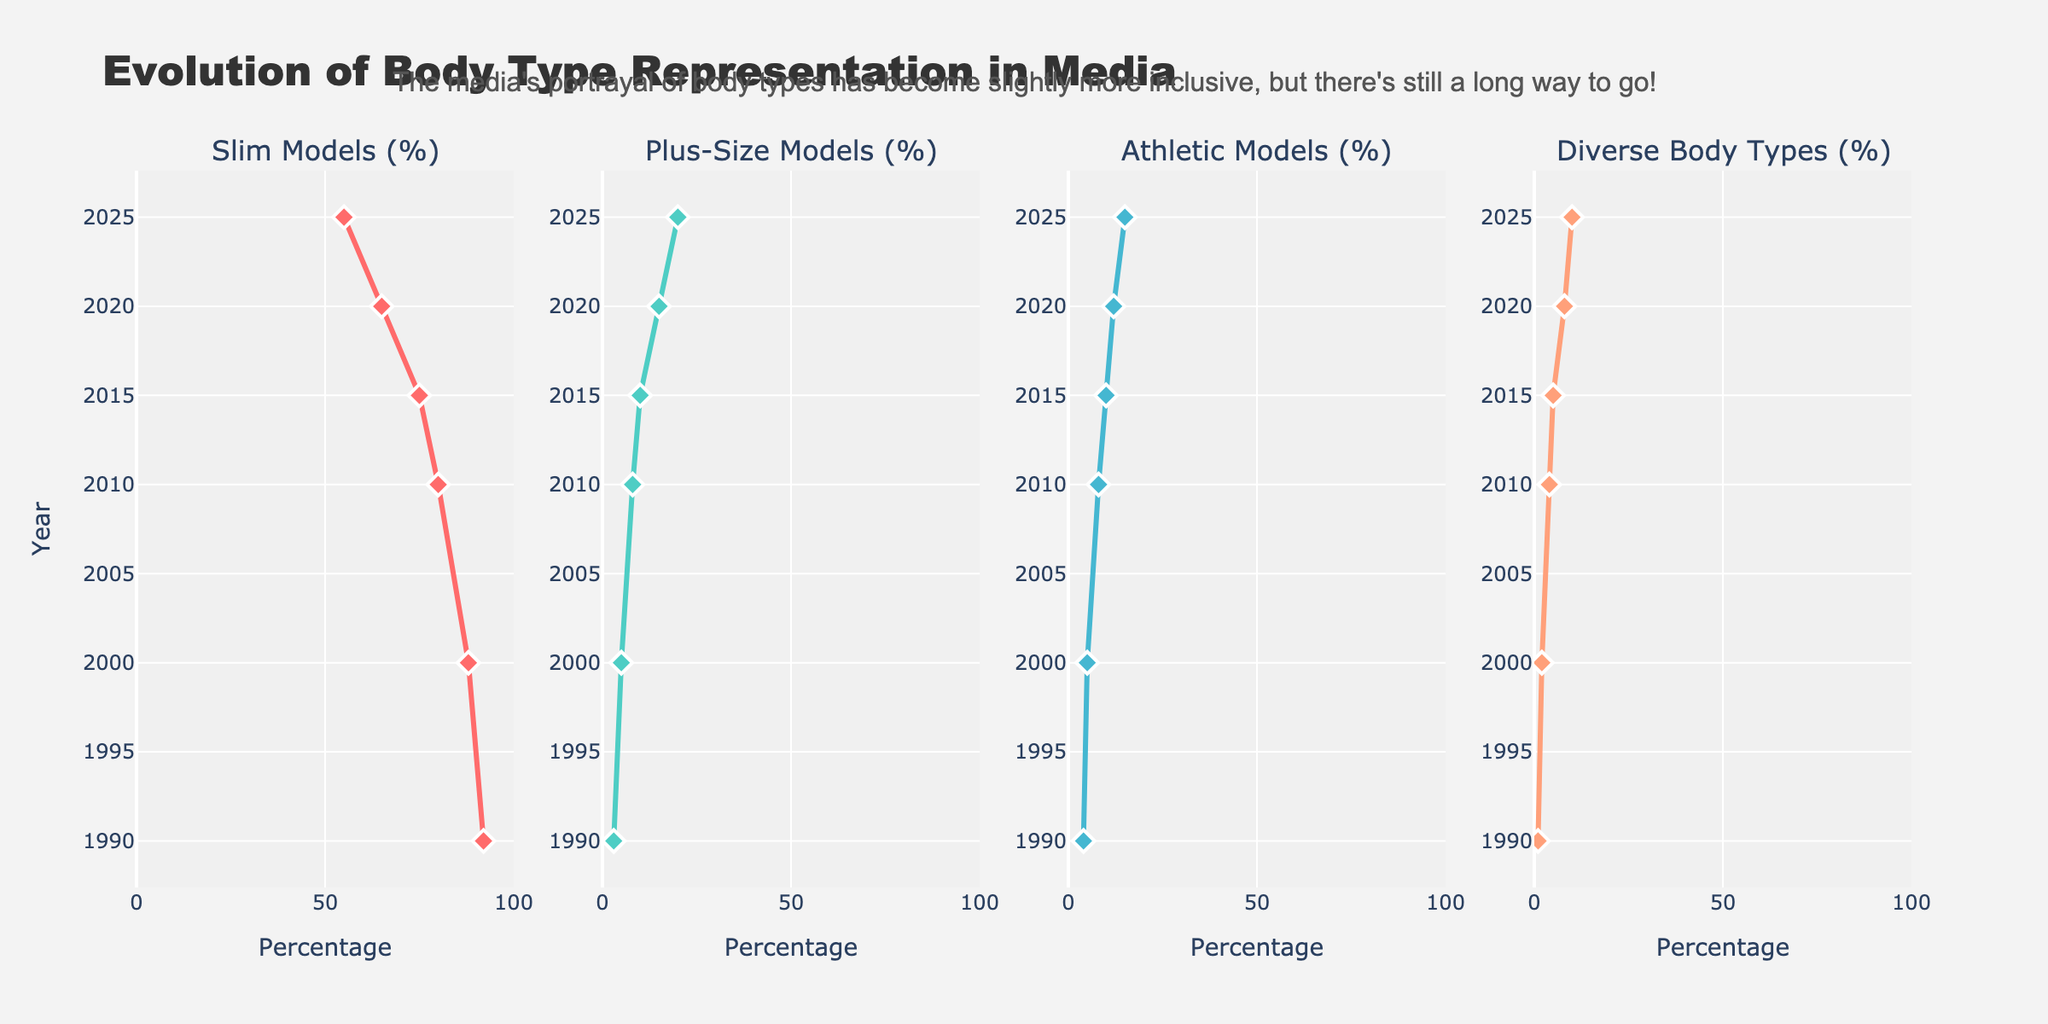What is the title of the figure? The title is located at the top of the figure and is intended to describe the main subject of the visualization.
Answer: Evolution of Body Type Representation in Media How has the percentage of slim models changed from 1990 to 2025? Look at the first subplot and compare the percentages shown for the years 1990 and 2025. In 1990, the percentage is 92%, and in 2025, it is 55%.
Answer: It has decreased from 92% to 55% Which year shows an equal percentage for both plus-size and athletic models? Check both the plus-size models (% in the second subplot) and athletic models (% in the third subplot) to find the year when both percentages match. The desired year should have equal percentages in both columns.
Answer: 2000 By what factor has the representation of diverse body types increased from 1990 to 2025? Calculate the ratio of the percentage of diverse body types in 2025 to that in 1990. The values are 10% for 2025 and 1% for 1990. Thus, Divide 10 by 1 to get the factor.
Answer: 10 In which year did the representation of athletic models first reach double digits? Examine the third subplot and identify the first year when the percentage is 10% or greater. This is in the year wise order of the data points.
Answer: 2015 Which body type has shown the greatest increase in representation between 1990 and 2025? Calculate the percentage increase for each body type: subtract the 1990 percentage from the 2025 percentage and find the type with the highest change.
Answer: Plus-Size Models How does the change in representation of plus-size models between 1990 and 2025 compare to the change in representation of diverse body types over the same period? Calculate the percentage increase for both plus-size models and diverse body types from 1990 to 2025. Plus-size models increased from 3% to 20% and diverse body types from 1% to 10%. Compare these differences (20-3 and 10-1).
Answer: Plus-Size Models increased by 17%, Divers Body Types increased by 9% What can be inferred from the annotation at the top of the figure? Read the annotation and interpret its message regarding the inclusivity of body types in media.
Answer: The media's portrayal is becoming more inclusive but still not fully representative Which body type had the smallest representation in 2000? Compare the percentages for slim models, plus-size models, athletic models, and diverse body types specifically for the year 2000 in all subplots.
Answer: Diverse Body Types If you had to predict a trend beyond 2025 based on the data, what would you predict for the representation of slim models and diverse body types? Analyze the trend lines for both slim models and diverse body types from previous years, extrapolate them to predict future trends beyond 2025. Slim models percentage is decreasing while diverse body types are increasing.
Answer: Slim models will likely decrease, and diverse body types will likely increase 